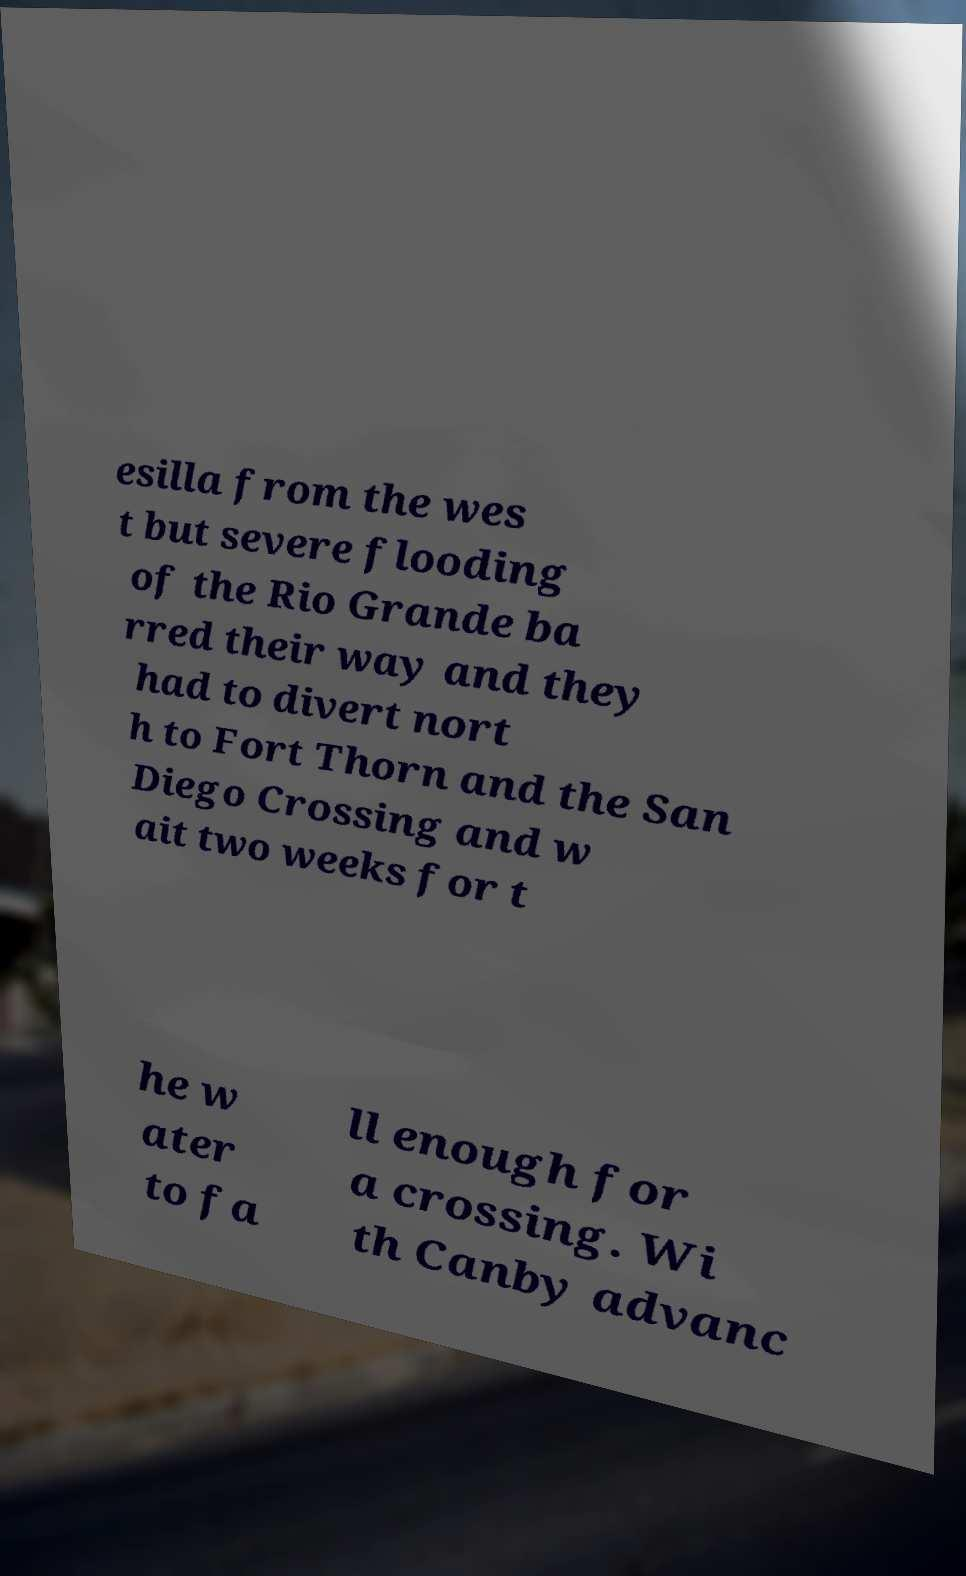Please read and relay the text visible in this image. What does it say? esilla from the wes t but severe flooding of the Rio Grande ba rred their way and they had to divert nort h to Fort Thorn and the San Diego Crossing and w ait two weeks for t he w ater to fa ll enough for a crossing. Wi th Canby advanc 